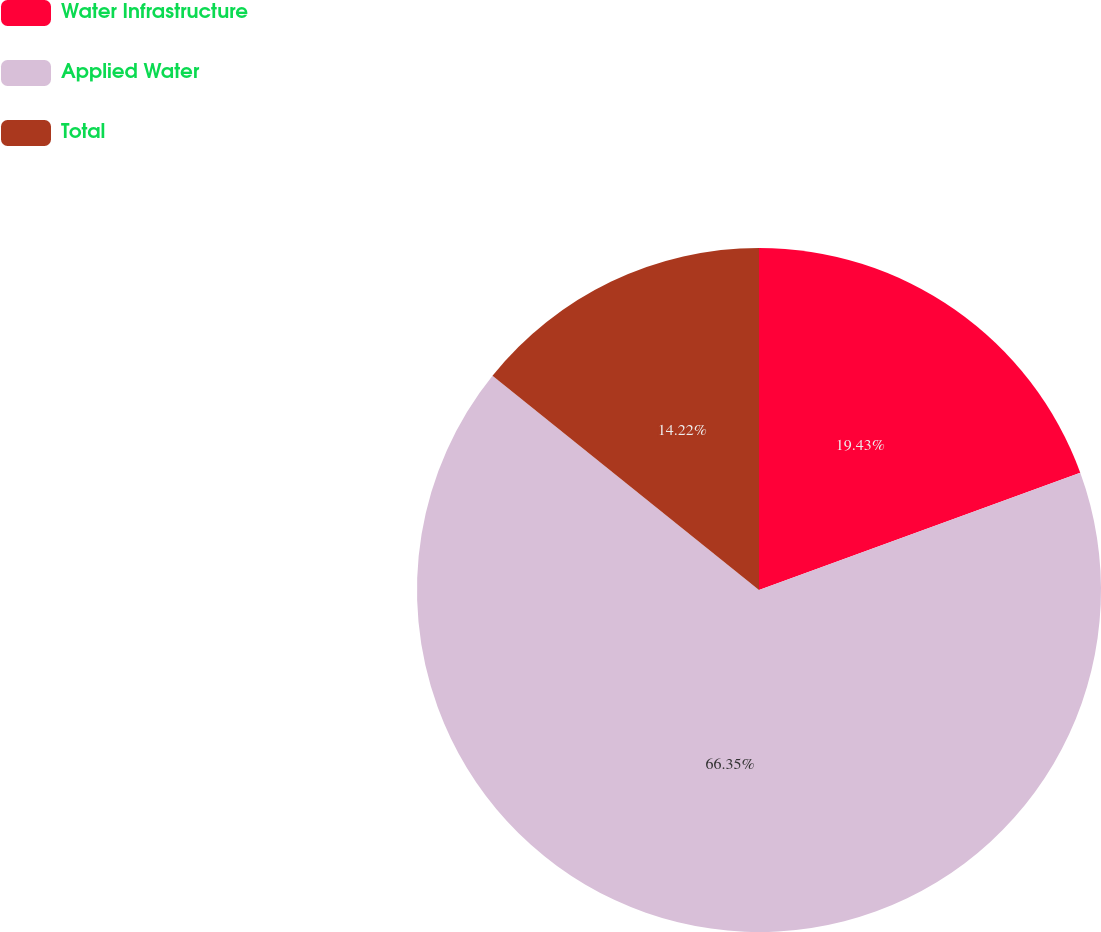<chart> <loc_0><loc_0><loc_500><loc_500><pie_chart><fcel>Water Infrastructure<fcel>Applied Water<fcel>Total<nl><fcel>19.43%<fcel>66.35%<fcel>14.22%<nl></chart> 